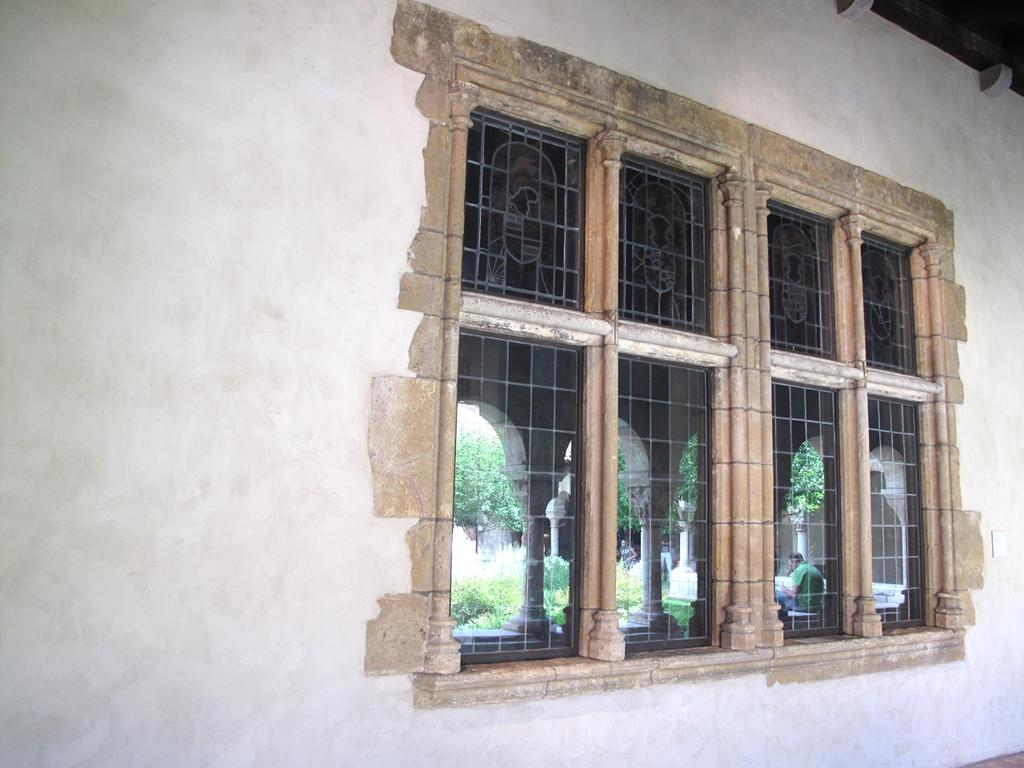What is located in the center of the image? There is a tree, grass, an arch, and persons in the center of the image. What type of vegetation is present in the center of the image? There is grass in the center of the image. What architectural feature can be seen in the center of the image? There is an arch in the center of the image. How many persons are present in the center of the image? There are persons in the center of the image. What can be seen in the background of the image? There is a wall and a window in the background of the image. Can you see a rose growing on the wall in the background of the image? There is no rose visible on the wall in the background of the image. Are the persons in the center of the image playing any games or sports? There is no indication in the image that the persons are playing any games or sports. 